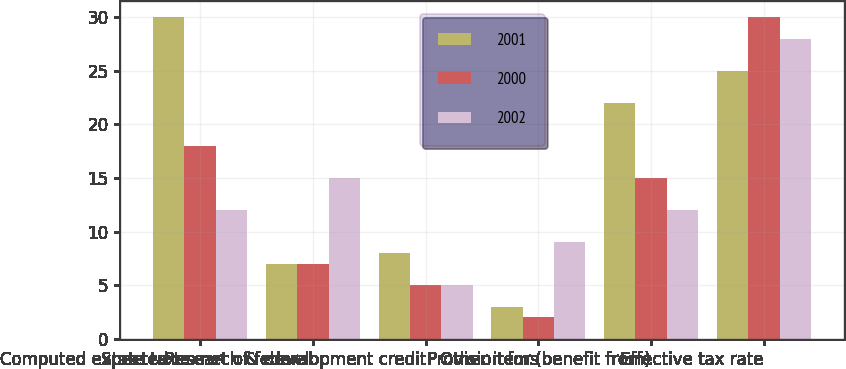Convert chart to OTSL. <chart><loc_0><loc_0><loc_500><loc_500><stacked_bar_chart><ecel><fcel>Computed expected tax<fcel>State taxes net of federal<fcel>Research & development credit<fcel>Other items<fcel>Provision for (benefit from)<fcel>Effective tax rate<nl><fcel>2001<fcel>30<fcel>7<fcel>8<fcel>3<fcel>22<fcel>25<nl><fcel>2000<fcel>18<fcel>7<fcel>5<fcel>2<fcel>15<fcel>30<nl><fcel>2002<fcel>12<fcel>15<fcel>5<fcel>9<fcel>12<fcel>28<nl></chart> 